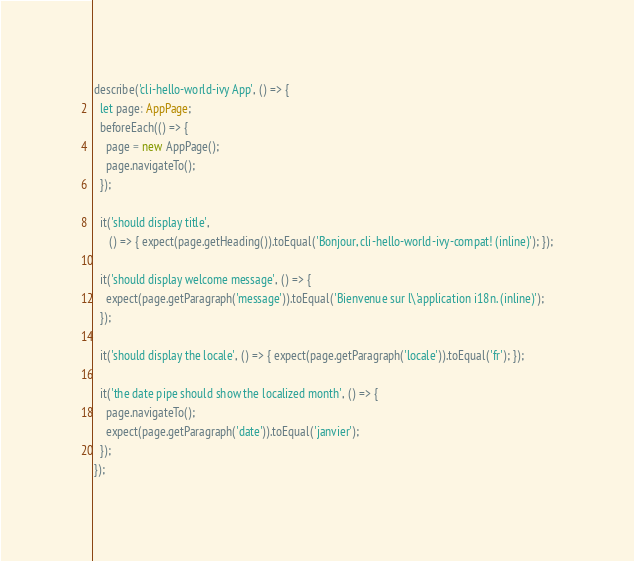Convert code to text. <code><loc_0><loc_0><loc_500><loc_500><_TypeScript_>describe('cli-hello-world-ivy App', () => {
  let page: AppPage;
  beforeEach(() => {
    page = new AppPage();
    page.navigateTo();
  });

  it('should display title',
     () => { expect(page.getHeading()).toEqual('Bonjour, cli-hello-world-ivy-compat! (inline)'); });

  it('should display welcome message', () => {
    expect(page.getParagraph('message')).toEqual('Bienvenue sur l\'application i18n. (inline)');
  });

  it('should display the locale', () => { expect(page.getParagraph('locale')).toEqual('fr'); });

  it('the date pipe should show the localized month', () => {
    page.navigateTo();
    expect(page.getParagraph('date')).toEqual('janvier');
  });
});
</code> 